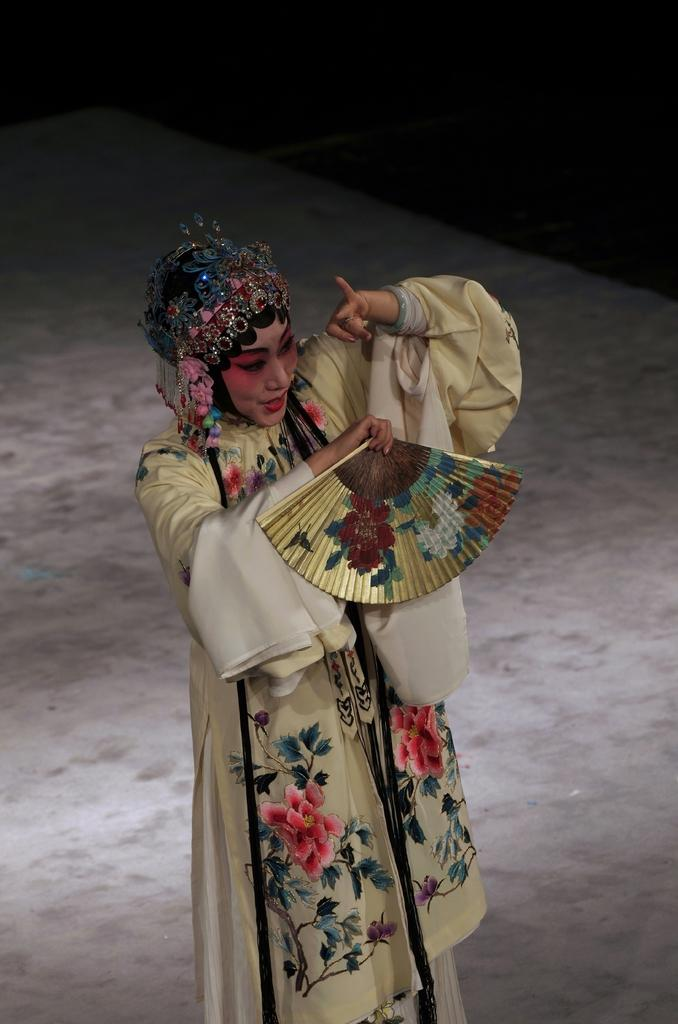Who is the main subject in the image? There is a woman in the image. What is the woman wearing? The woman is wearing a dress. What is the woman's facial expression in the image? The woman is smiling. Where is the woman located in the image? The woman is performing on a stage. What is the color of the background in the image? The background of the image is dark in color. What type of fiction is the governor reading on stage in the image? There is no governor or fiction present in the image; it features a woman performing on a stage. What type of wheel is visible on the stage in the image? There is no wheel visible on the stage in the image. 